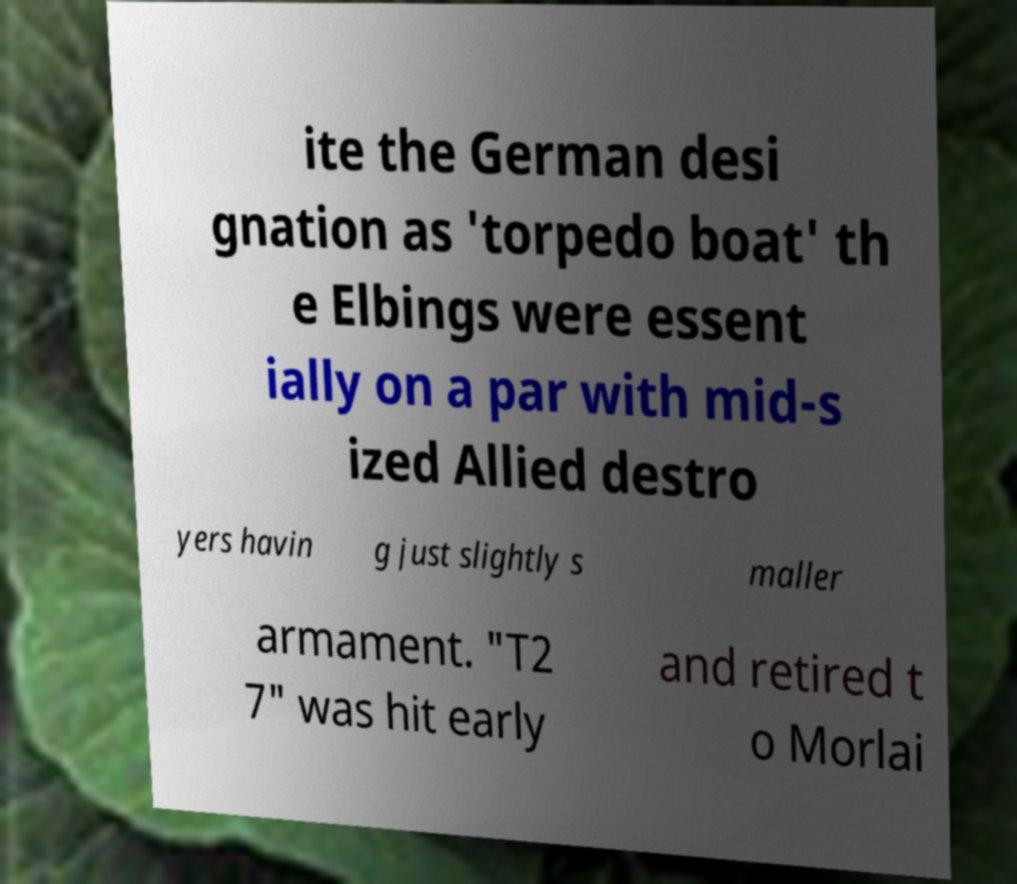Could you assist in decoding the text presented in this image and type it out clearly? ite the German desi gnation as 'torpedo boat' th e Elbings were essent ially on a par with mid-s ized Allied destro yers havin g just slightly s maller armament. "T2 7" was hit early and retired t o Morlai 